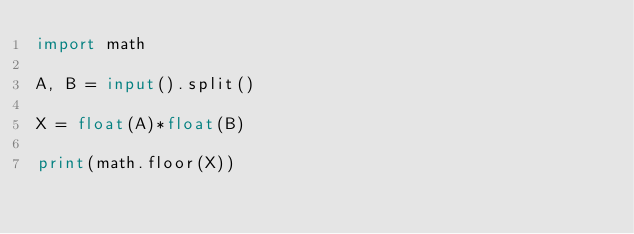<code> <loc_0><loc_0><loc_500><loc_500><_Python_>import math

A, B = input().split()

X = float(A)*float(B)

print(math.floor(X))</code> 